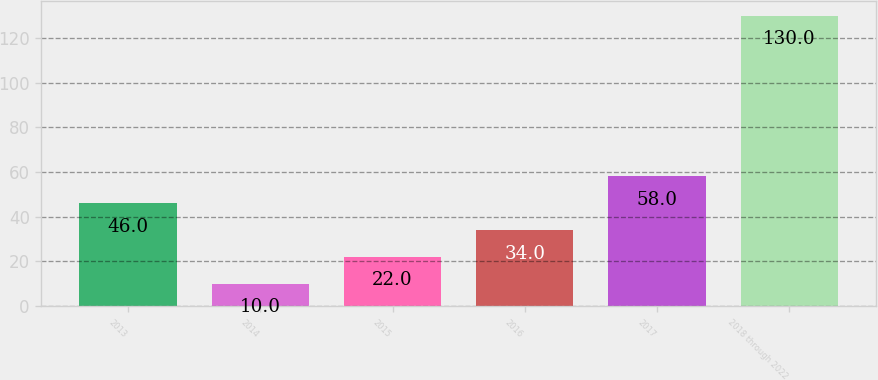Convert chart. <chart><loc_0><loc_0><loc_500><loc_500><bar_chart><fcel>2013<fcel>2014<fcel>2015<fcel>2016<fcel>2017<fcel>2018 through 2022<nl><fcel>46<fcel>10<fcel>22<fcel>34<fcel>58<fcel>130<nl></chart> 